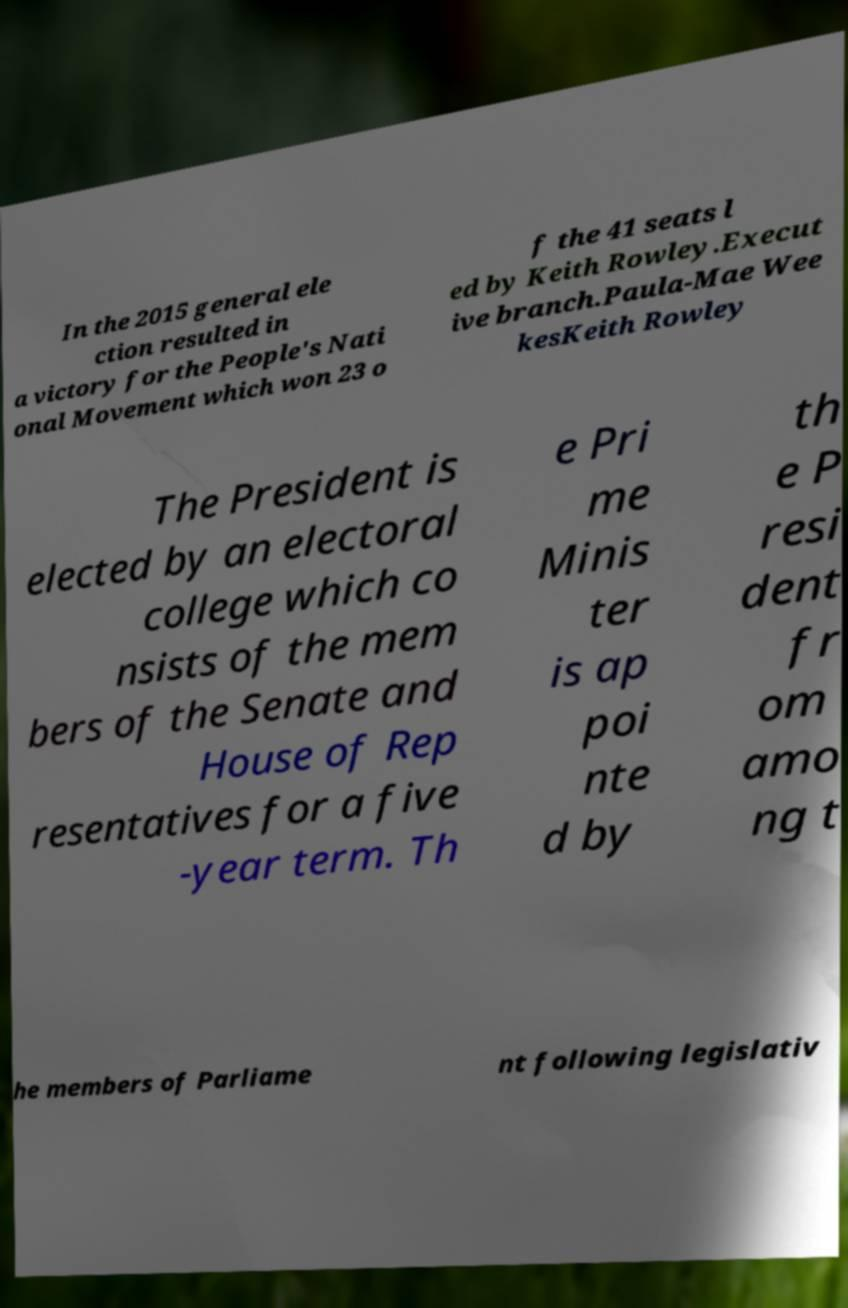Can you read and provide the text displayed in the image?This photo seems to have some interesting text. Can you extract and type it out for me? In the 2015 general ele ction resulted in a victory for the People's Nati onal Movement which won 23 o f the 41 seats l ed by Keith Rowley.Execut ive branch.Paula-Mae Wee kesKeith Rowley The President is elected by an electoral college which co nsists of the mem bers of the Senate and House of Rep resentatives for a five -year term. Th e Pri me Minis ter is ap poi nte d by th e P resi dent fr om amo ng t he members of Parliame nt following legislativ 